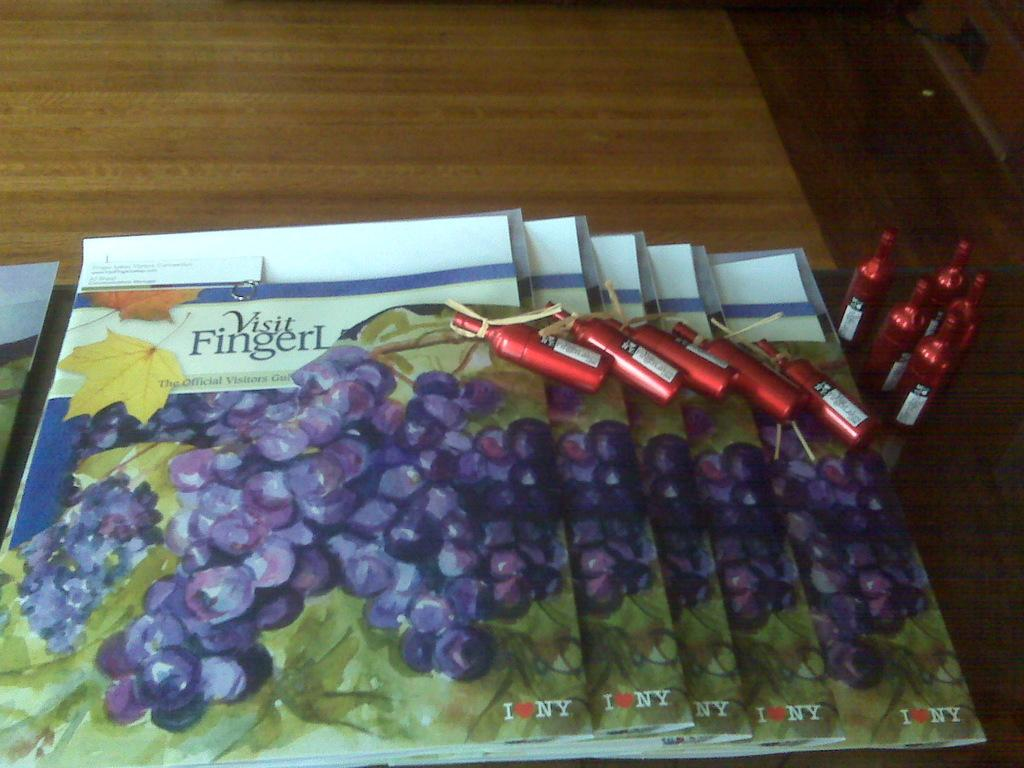What objects can be seen in the image? There are books and tiny bottles in the image. What is the color of the tiny bottles? The tiny bottles are red in color. Where are the books and bottles located? The books and bottles are placed on a table. How many frogs are sitting on the hat in the image? There are no frogs or hats present in the image. What type of truck can be seen driving through the image? There is no truck visible in the image. 